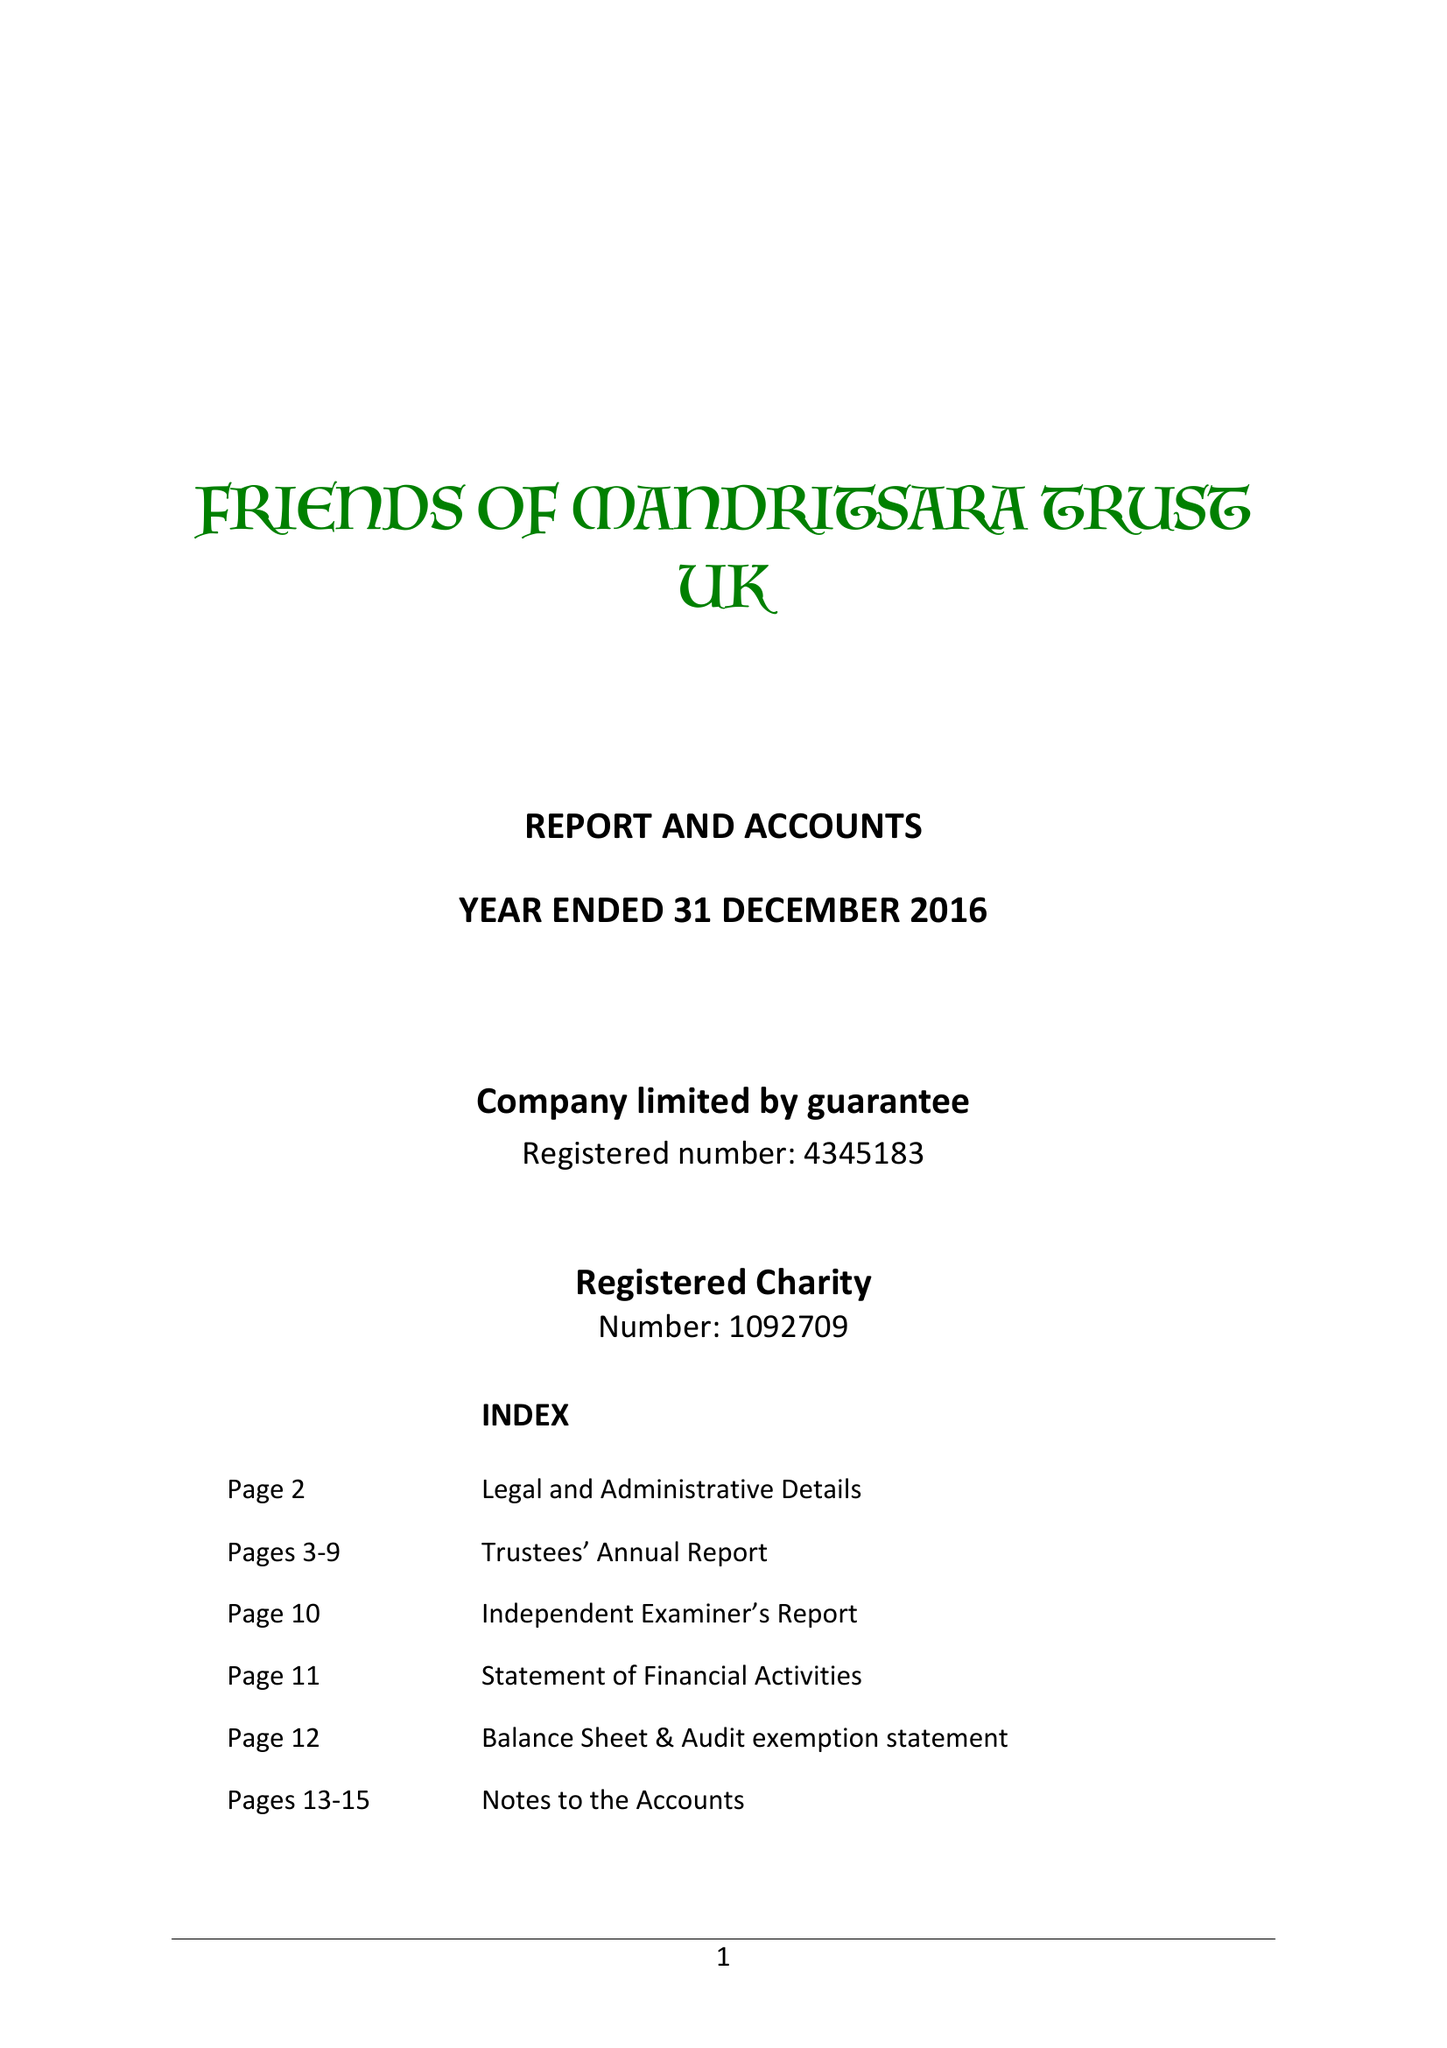What is the value for the charity_name?
Answer the question using a single word or phrase. Friends Of Mandritsara Trust 